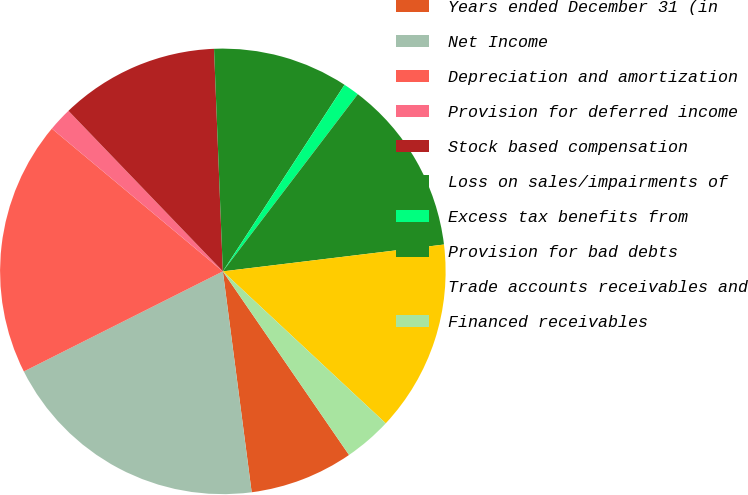Convert chart to OTSL. <chart><loc_0><loc_0><loc_500><loc_500><pie_chart><fcel>Years ended December 31 (in<fcel>Net Income<fcel>Depreciation and amortization<fcel>Provision for deferred income<fcel>Stock based compensation<fcel>Loss on sales/impairments of<fcel>Excess tax benefits from<fcel>Provision for bad debts<fcel>Trade accounts receivables and<fcel>Financed receivables<nl><fcel>7.52%<fcel>19.65%<fcel>18.49%<fcel>1.74%<fcel>11.56%<fcel>9.83%<fcel>1.16%<fcel>12.72%<fcel>13.87%<fcel>3.47%<nl></chart> 